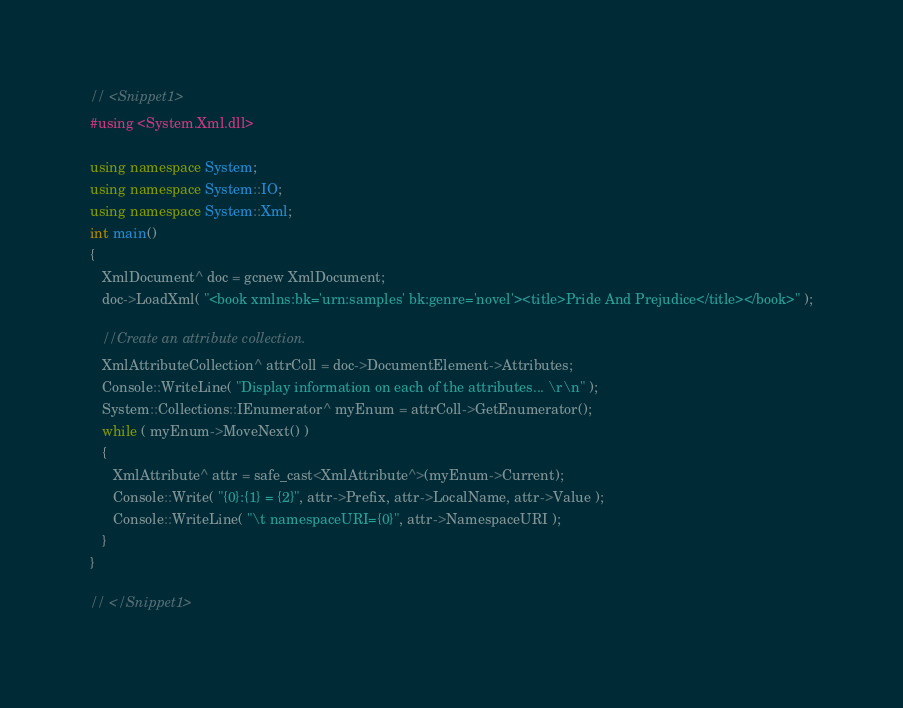Convert code to text. <code><loc_0><loc_0><loc_500><loc_500><_C++_>

// <Snippet1>
#using <System.Xml.dll>

using namespace System;
using namespace System::IO;
using namespace System::Xml;
int main()
{
   XmlDocument^ doc = gcnew XmlDocument;
   doc->LoadXml( "<book xmlns:bk='urn:samples' bk:genre='novel'><title>Pride And Prejudice</title></book>" );
   
   //Create an attribute collection.
   XmlAttributeCollection^ attrColl = doc->DocumentElement->Attributes;
   Console::WriteLine( "Display information on each of the attributes... \r\n" );
   System::Collections::IEnumerator^ myEnum = attrColl->GetEnumerator();
   while ( myEnum->MoveNext() )
   {
      XmlAttribute^ attr = safe_cast<XmlAttribute^>(myEnum->Current);
      Console::Write( "{0}:{1} = {2}", attr->Prefix, attr->LocalName, attr->Value );
      Console::WriteLine( "\t namespaceURI={0}", attr->NamespaceURI );
   }
}

// </Snippet1>
</code> 